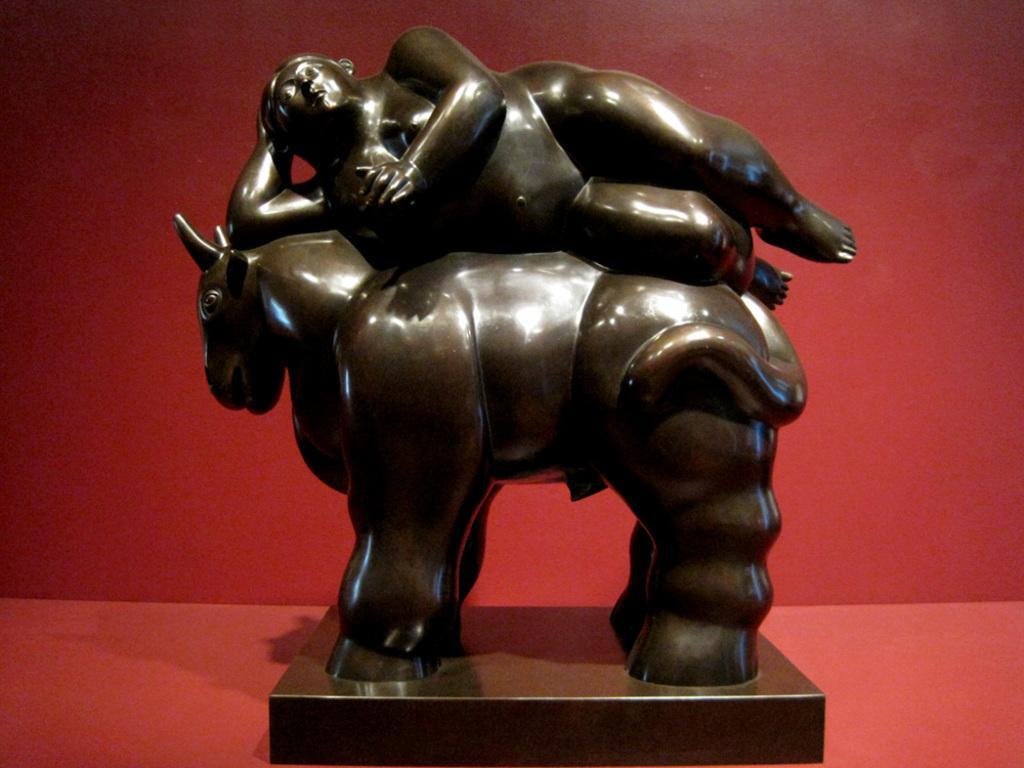Could you give a brief overview of what you see in this image? In this picture I can observe sculpture of an animal and a human. The background is in red color. 